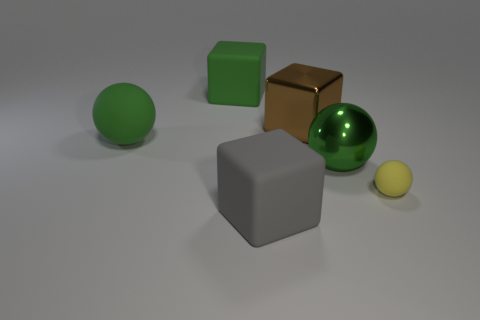Are there any other things that are the same size as the yellow object?
Ensure brevity in your answer.  No. What number of other objects are there of the same material as the green block?
Provide a succinct answer. 3. There is a big matte object that is behind the small rubber sphere and in front of the big brown metal object; what color is it?
Give a very brief answer. Green. Does the big ball on the left side of the brown cube have the same material as the sphere in front of the large green shiny sphere?
Provide a succinct answer. Yes. Is the size of the matte sphere that is on the left side of the yellow ball the same as the big shiny block?
Provide a succinct answer. Yes. There is a tiny matte ball; does it have the same color as the shiny thing that is on the left side of the large green metal ball?
Give a very brief answer. No. What is the shape of the shiny object that is the same color as the big matte sphere?
Provide a short and direct response. Sphere. The large brown thing has what shape?
Your answer should be very brief. Cube. Is the small sphere the same color as the large rubber sphere?
Provide a short and direct response. No. What number of objects are cubes that are behind the brown block or red matte cylinders?
Your response must be concise. 1. 